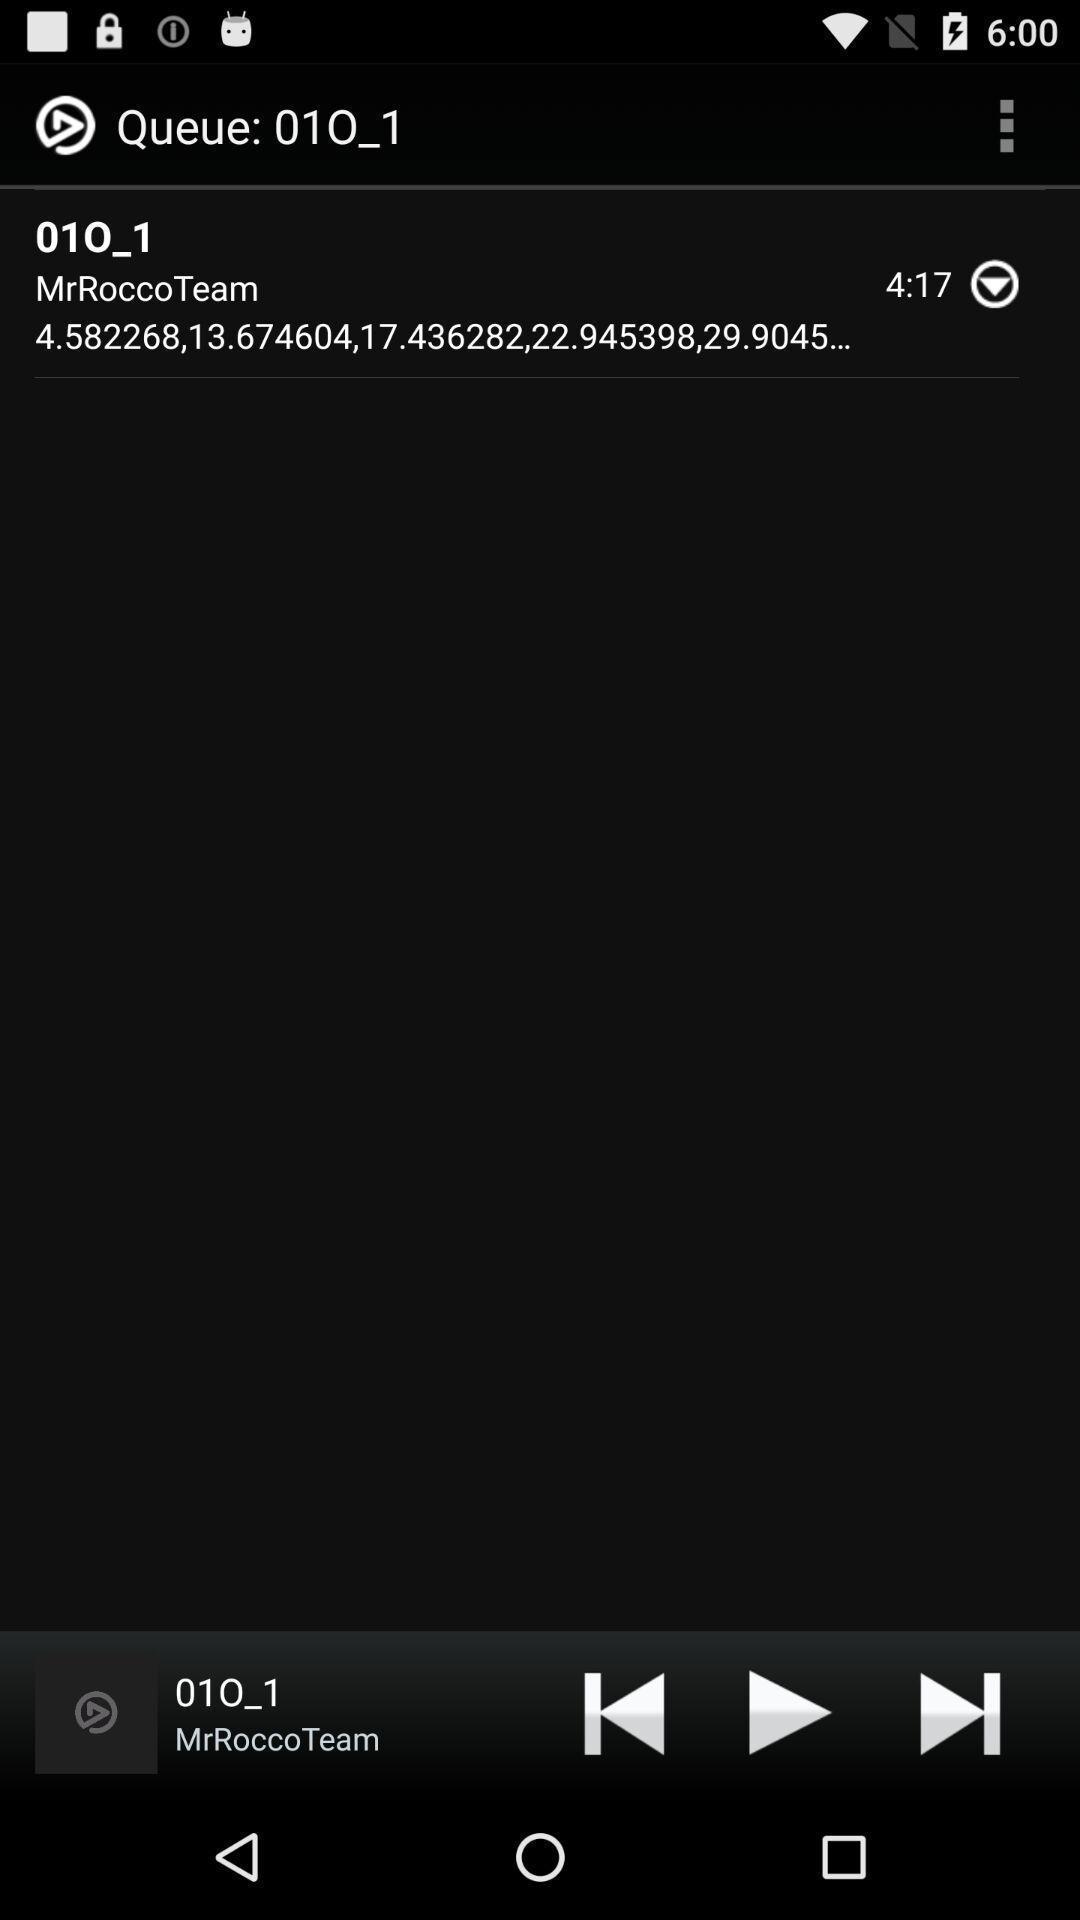What can you discern from this picture? Page displays audio player on screen. 